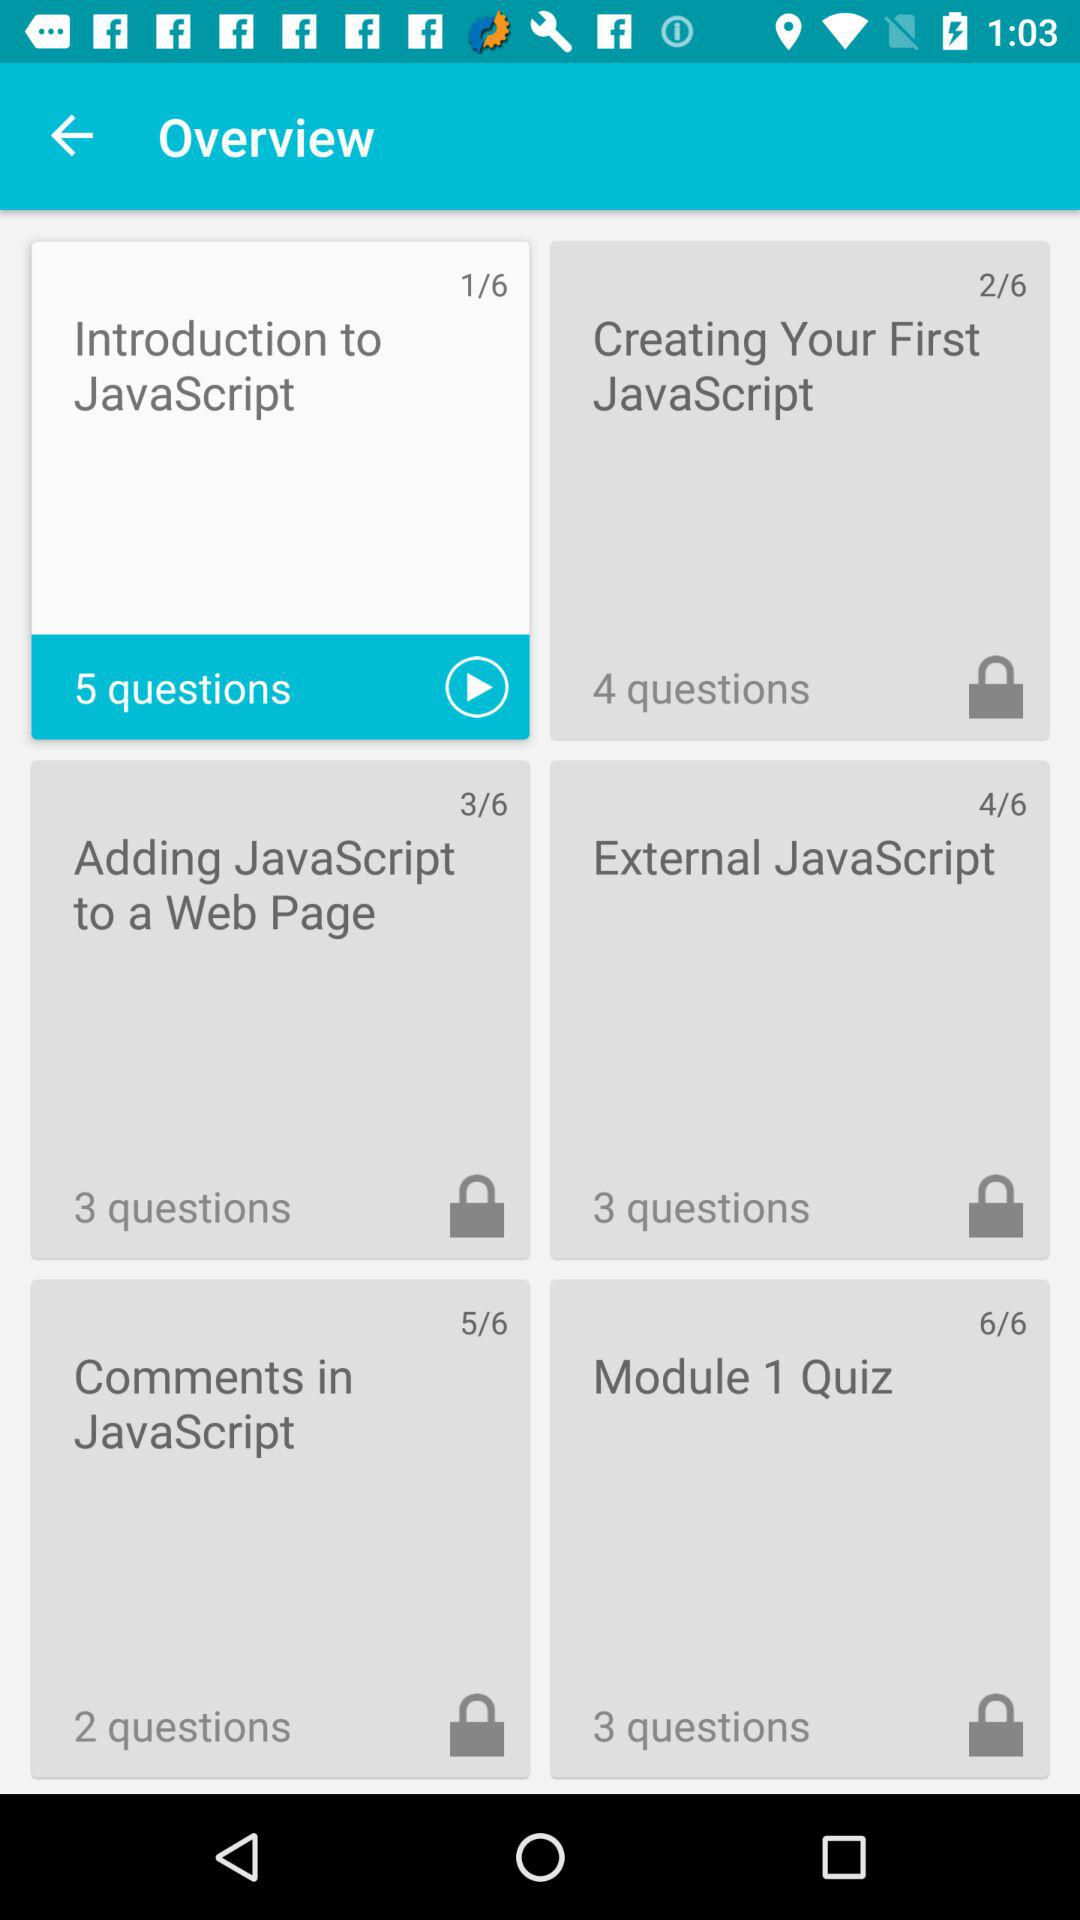Which lesson has the least number of questions?
Answer the question using a single word or phrase. Comments in JavaScript 